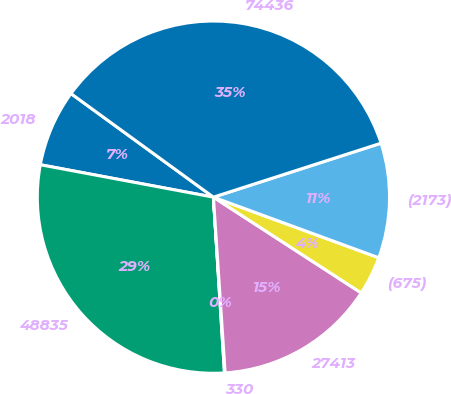Convert chart. <chart><loc_0><loc_0><loc_500><loc_500><pie_chart><fcel>2018<fcel>48835<fcel>330<fcel>27413<fcel>(675)<fcel>(2173)<fcel>74436<nl><fcel>7.06%<fcel>28.95%<fcel>0.06%<fcel>14.79%<fcel>3.56%<fcel>10.55%<fcel>35.04%<nl></chart> 